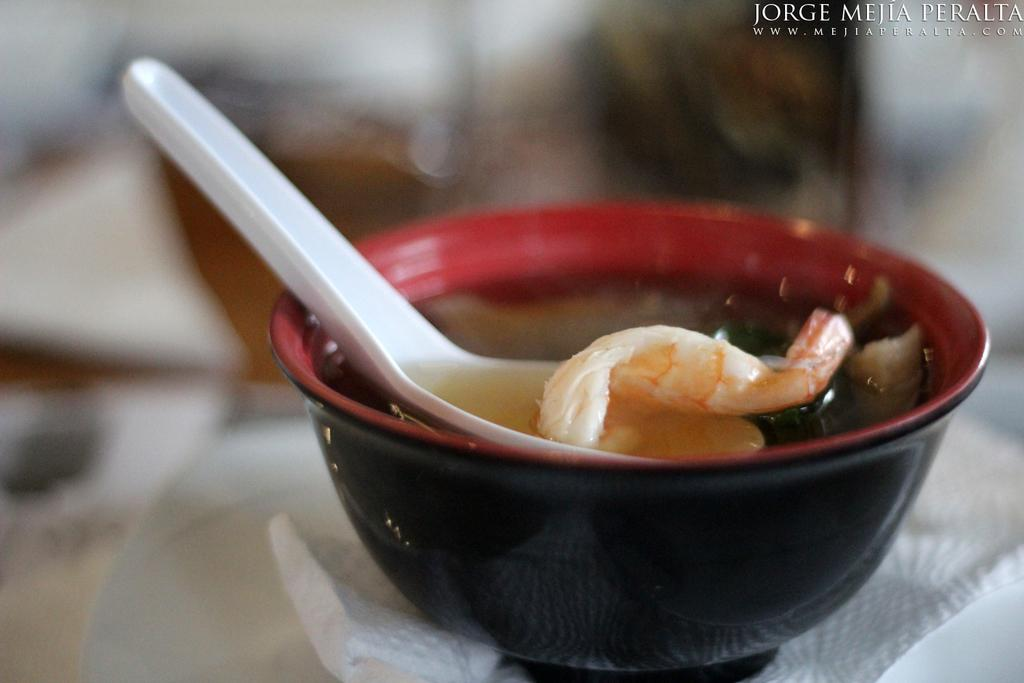What is in the bowl that is visible in the image? There is a bowl with liquid food in the image. What utensil is placed beside the bowl in the image? There is a spoon beside the bowl in the image. What type of air can be seen coming out of the bowl in the image? There is no air coming out of the bowl in the image; it contains liquid food. 